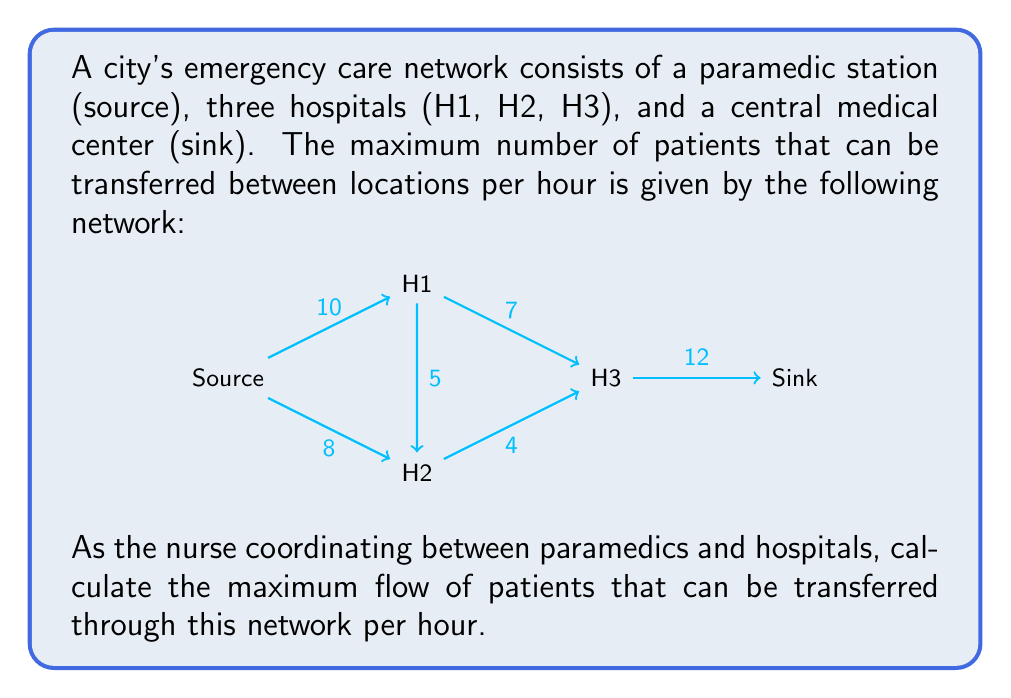What is the answer to this math problem? To solve this problem, we'll use the Ford-Fulkerson algorithm to find the maximum flow in the network.

Step 1: Initialize the flow to 0 for all edges.

Step 2: Find an augmenting path from source to sink. We'll use depth-first search (DFS).

Iteration 1:
Path: Source -> H1 -> H3 -> Sink
Flow: min(10, 7, 12) = 7
Update residual graph and add 7 to max flow.

Iteration 2:
Path: Source -> H2 -> H3 -> Sink
Flow: min(8, 4, 5) = 4
Update residual graph and add 4 to max flow.

Iteration 3:
Path: Source -> H1 -> H2 -> H3 -> Sink
Flow: min(3, 5, 1) = 1
Update residual graph and add 1 to max flow.

Iteration 4:
No more augmenting paths found.

Step 3: Sum up the flows from all iterations.

Maximum flow = 7 + 4 + 1 = 12

Therefore, the maximum number of patients that can be transferred through this network per hour is 12.

This solution ensures that the nurse can coordinate the most efficient use of the emergency care network, maximizing the number of patients that can receive timely care.
Answer: The maximum flow of patients through the emergency care network is 12 patients per hour. 